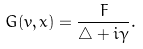Convert formula to latex. <formula><loc_0><loc_0><loc_500><loc_500>G ( v , x ) = \frac { F } { \bigtriangleup + i \gamma } .</formula> 